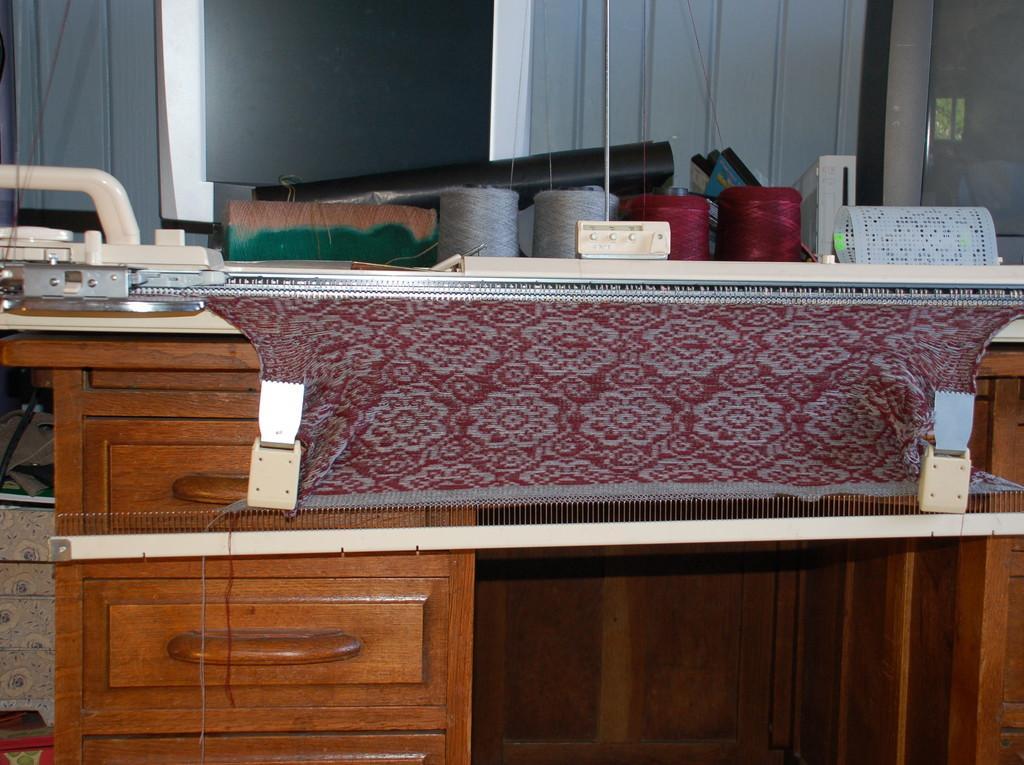Could you give a brief overview of what you see in this image? In this image I can see a table and and on it I can see a machine and a cloth. In the background I can see few threads. 